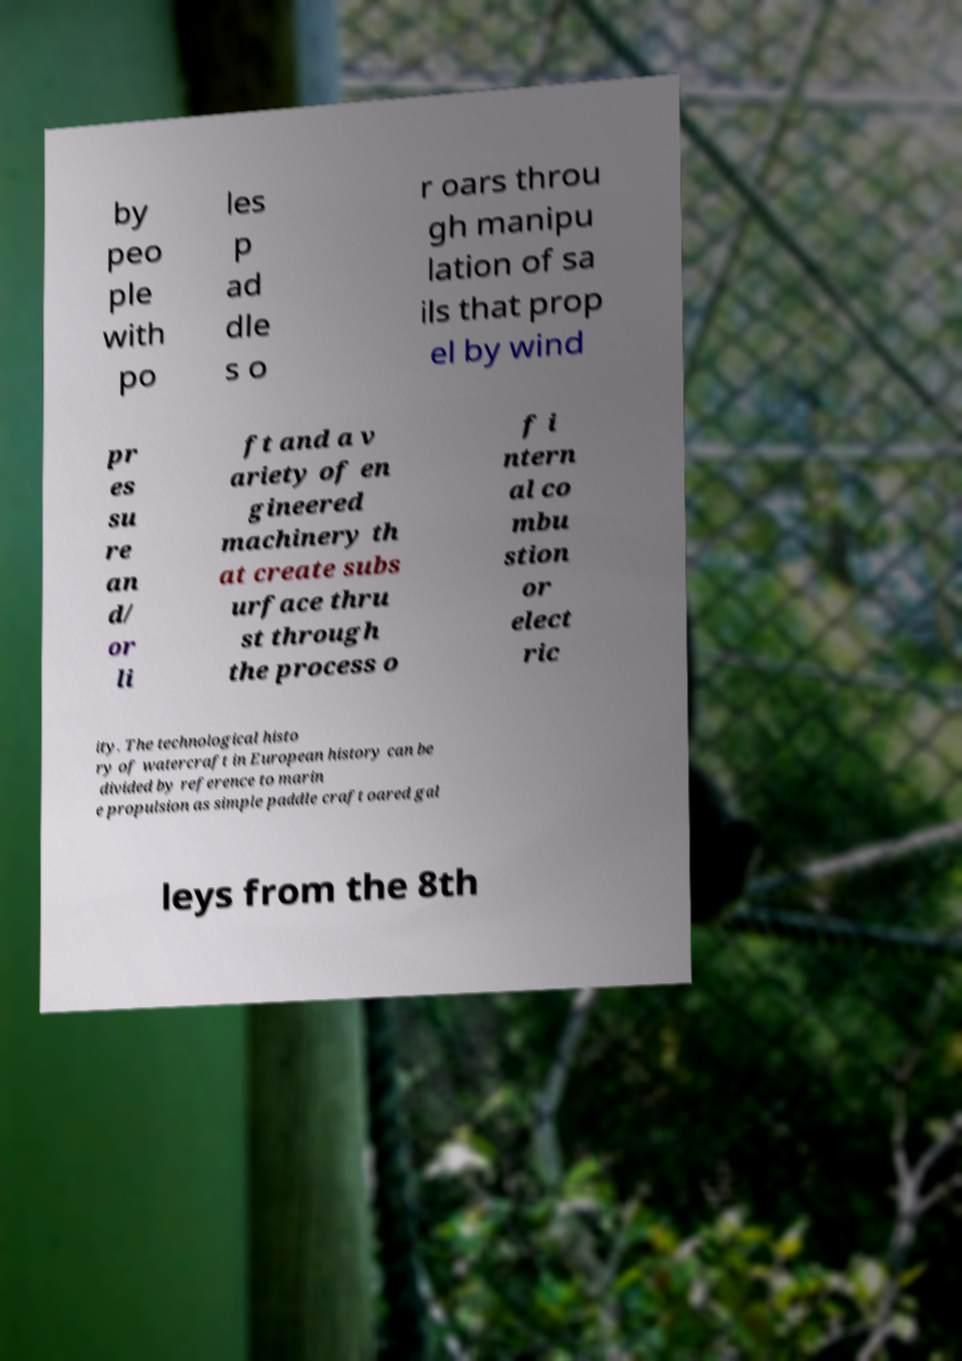Could you assist in decoding the text presented in this image and type it out clearly? by peo ple with po les p ad dle s o r oars throu gh manipu lation of sa ils that prop el by wind pr es su re an d/ or li ft and a v ariety of en gineered machinery th at create subs urface thru st through the process o f i ntern al co mbu stion or elect ric ity. The technological histo ry of watercraft in European history can be divided by reference to marin e propulsion as simple paddle craft oared gal leys from the 8th 